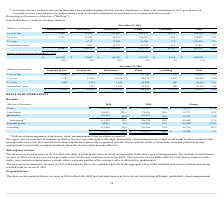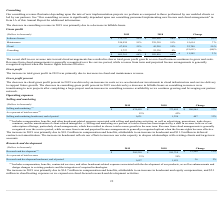According to Pegasystems's financial document, How is revenue from cloud arrangements recognised? recognized over the service period. The document states: "erm. Revenue from cloud arrangements is generally recognized over the service period, while revenue from term and perpetual license arrangements is ge..." Also, How is revenue from term and perpetual license arrangements recognised? recognized upfront when the license rights become effective. The document states: "m and perpetual license arrangements is generally recognized upfront when the license rights become effective...." Also, What can the increase in maintenance revenue in 2019 be primarily attributed to? the continued growth in the aggregate value of the installed base of our software and strong renewal rates in excess of 90%. The document states: "n maintenance revenue in 2019 was primarily due to the continued growth in the aggregate value of the installed base of our software and strong renewa..." Also, can you calculate: What is the percentage change in revenue from Cloud services between 2018 and 2019? To answer this question, I need to perform calculations using the financial data. The calculation is: (133,746 - 82,627)/82,627 , which equals 61.87 (percentage). This is based on the information: "Cloud $ 133,746 15% $ 82,627 9% $ 51,119 62 % Cloud $ 133,746 15% $ 82,627 9% $ 51,119 62 %..." The key data points involved are: 133,746, 82,627. Also, can you calculate: What is the percentage change in revenue from term license between 2018 and 2019? To answer this question, I need to perform calculations using the financial data. The calculation is: (199,433 - 178,256)/178,256 , which equals 11.88 (percentage). This is based on the information: "Term license 199,433 22% 178,256 20% 21,177 12 % Term license 199,433 22% 178,256 20% 21,177 12 %..." The key data points involved are: 178,256, 199,433. Also, can you calculate: What is the percentage change in revenue from maintenance between 2018 and 2019? To answer this question, I need to perform calculations using the financial data. The calculation is: (280,580 - 263,875)/263,875 , which equals 6.33 (percentage). This is based on the information: "Maintenance 280,580 30% 263,875 30% 16,705 6 % Maintenance 280,580 30% 263,875 30% 16,705 6 %..." The key data points involved are: 263,875, 280,580. 